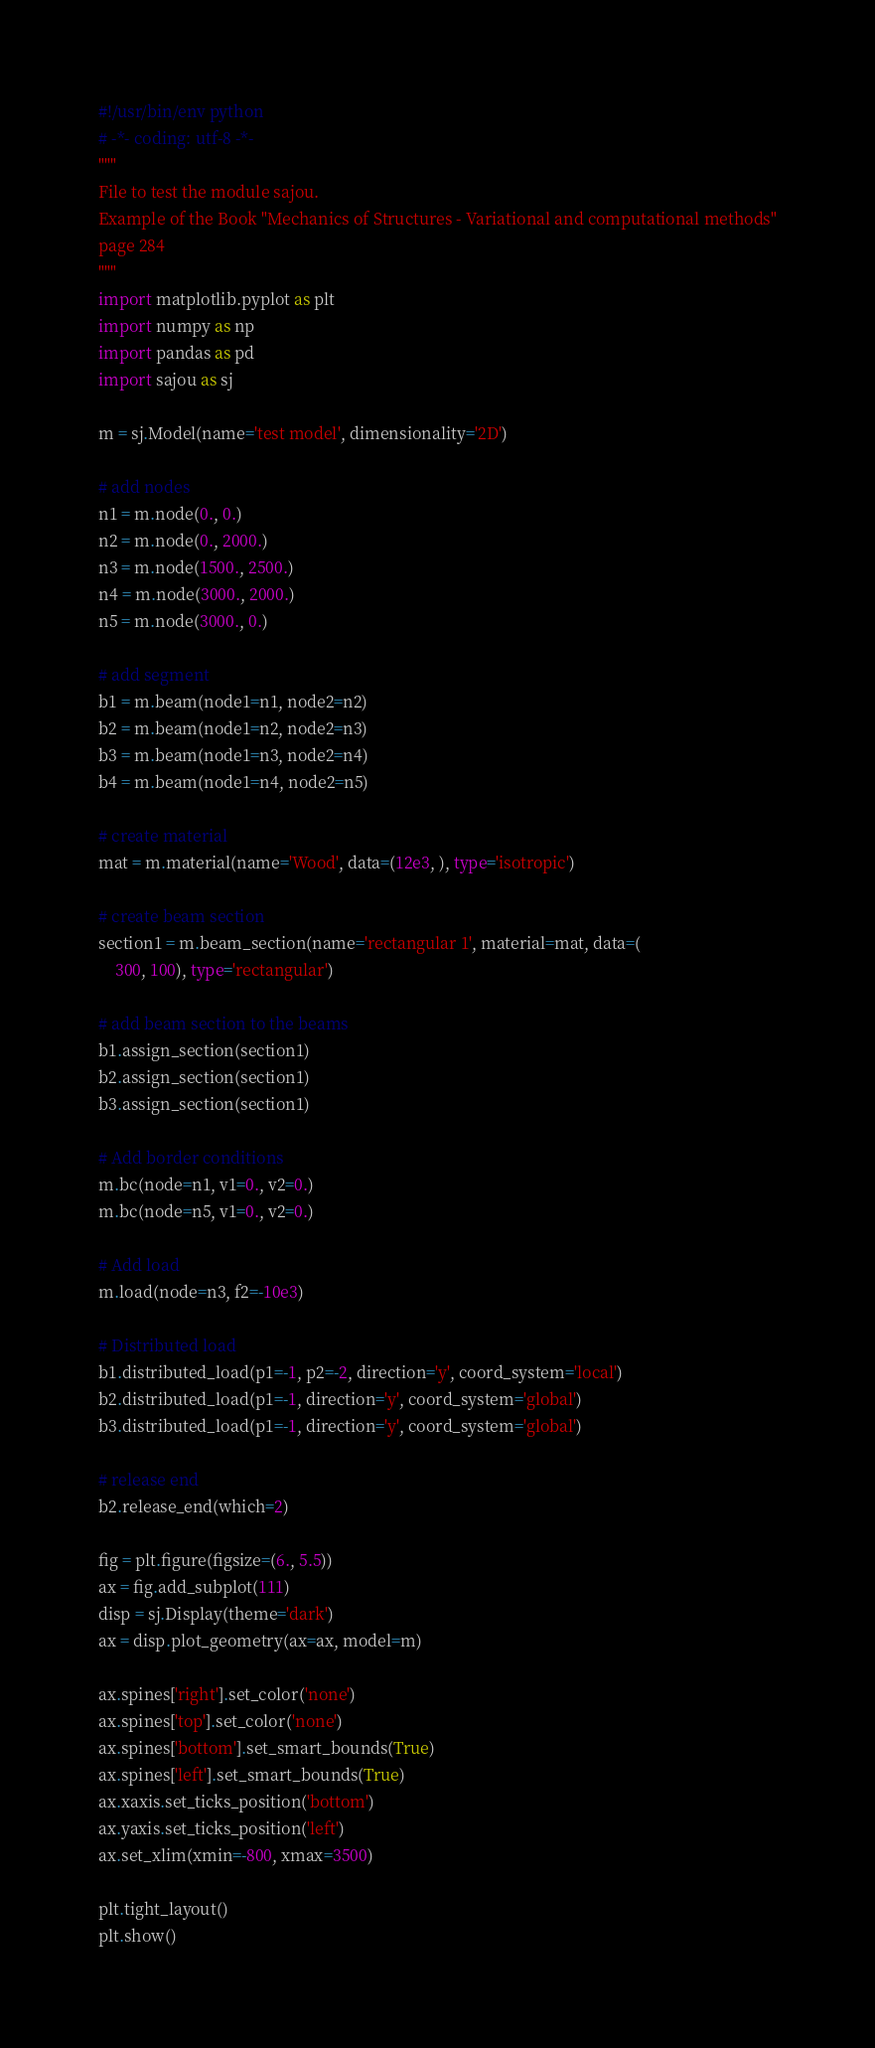Convert code to text. <code><loc_0><loc_0><loc_500><loc_500><_Python_>#!/usr/bin/env python
# -*- coding: utf-8 -*-
"""
File to test the module sajou.
Example of the Book "Mechanics of Structures - Variational and computational methods"
page 284
"""
import matplotlib.pyplot as plt
import numpy as np
import pandas as pd
import sajou as sj

m = sj.Model(name='test model', dimensionality='2D')

# add nodes
n1 = m.node(0., 0.)
n2 = m.node(0., 2000.)
n3 = m.node(1500., 2500.)
n4 = m.node(3000., 2000.)
n5 = m.node(3000., 0.)

# add segment
b1 = m.beam(node1=n1, node2=n2)
b2 = m.beam(node1=n2, node2=n3)
b3 = m.beam(node1=n3, node2=n4)
b4 = m.beam(node1=n4, node2=n5)

# create material
mat = m.material(name='Wood', data=(12e3, ), type='isotropic')

# create beam section
section1 = m.beam_section(name='rectangular 1', material=mat, data=(
    300, 100), type='rectangular')

# add beam section to the beams
b1.assign_section(section1)
b2.assign_section(section1)
b3.assign_section(section1)

# Add border conditions
m.bc(node=n1, v1=0., v2=0.)
m.bc(node=n5, v1=0., v2=0.)

# Add load
m.load(node=n3, f2=-10e3)

# Distributed load
b1.distributed_load(p1=-1, p2=-2, direction='y', coord_system='local')
b2.distributed_load(p1=-1, direction='y', coord_system='global')
b3.distributed_load(p1=-1, direction='y', coord_system='global')

# release end
b2.release_end(which=2)

fig = plt.figure(figsize=(6., 5.5))
ax = fig.add_subplot(111)
disp = sj.Display(theme='dark')
ax = disp.plot_geometry(ax=ax, model=m)

ax.spines['right'].set_color('none')
ax.spines['top'].set_color('none')
ax.spines['bottom'].set_smart_bounds(True)
ax.spines['left'].set_smart_bounds(True)
ax.xaxis.set_ticks_position('bottom')
ax.yaxis.set_ticks_position('left')
ax.set_xlim(xmin=-800, xmax=3500)

plt.tight_layout()
plt.show()
</code> 